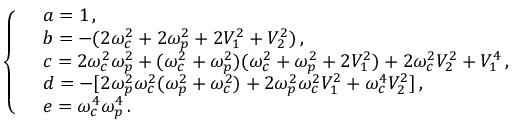<formula> <loc_0><loc_0><loc_500><loc_500>\left \{ \begin{array} { r l } & { a = 1 \, , } \\ & { b = - ( 2 { \omega } _ { c } ^ { 2 } + 2 { \omega } _ { p } ^ { 2 } + 2 V _ { 1 } ^ { 2 } + V _ { 2 } ^ { 2 } ) \, , } \\ & { c = 2 { \omega } _ { c } ^ { 2 } { \omega } _ { p } ^ { 2 } + ( { \omega } _ { c } ^ { 2 } + { \omega } _ { p } ^ { 2 } ) ( { \omega } _ { c } ^ { 2 } + { \omega } _ { p } ^ { 2 } + 2 V _ { 1 } ^ { 2 } ) + 2 { \omega } _ { c } ^ { 2 } V _ { 2 } ^ { 2 } + V _ { 1 } ^ { 4 } \, , } \\ & { d = - [ 2 { \omega } _ { p } ^ { 2 } { \omega } _ { c } ^ { 2 } ( { \omega } _ { p } ^ { 2 } + { \omega } _ { c } ^ { 2 } ) + 2 { \omega } _ { p } ^ { 2 } { \omega } _ { c } ^ { 2 } V _ { 1 } ^ { 2 } + { \omega } _ { c } ^ { 4 } V _ { 2 } ^ { 2 } ] \, , } \\ & { e = { \omega } _ { c } ^ { 4 } { \omega } _ { p } ^ { 4 } \, . } \end{array}</formula> 